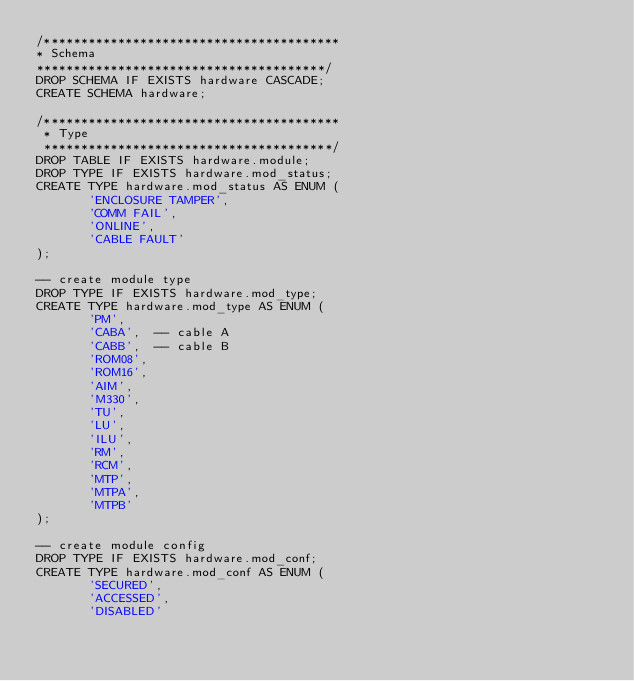<code> <loc_0><loc_0><loc_500><loc_500><_SQL_>/****************************************
* Schema
***************************************/
DROP SCHEMA IF EXISTS hardware CASCADE;
CREATE SCHEMA hardware;

/****************************************
 * Type
 ***************************************/
DROP TABLE IF EXISTS hardware.module;
DROP TYPE IF EXISTS hardware.mod_status;
CREATE TYPE hardware.mod_status AS ENUM (
       'ENCLOSURE TAMPER',
       'COMM FAIL',
       'ONLINE',
       'CABLE FAULT'
);

-- create module type
DROP TYPE IF EXISTS hardware.mod_type;
CREATE TYPE hardware.mod_type AS ENUM (
       'PM',
       'CABA',  -- cable A
       'CABB',  -- cable B
       'ROM08',
       'ROM16',
       'AIM',
       'M330',
       'TU',
       'LU',
       'ILU',
       'RM',
       'RCM',
       'MTP',
       'MTPA',
       'MTPB'
);

-- create module config
DROP TYPE IF EXISTS hardware.mod_conf;
CREATE TYPE hardware.mod_conf AS ENUM (
       'SECURED',
       'ACCESSED',
       'DISABLED'</code> 